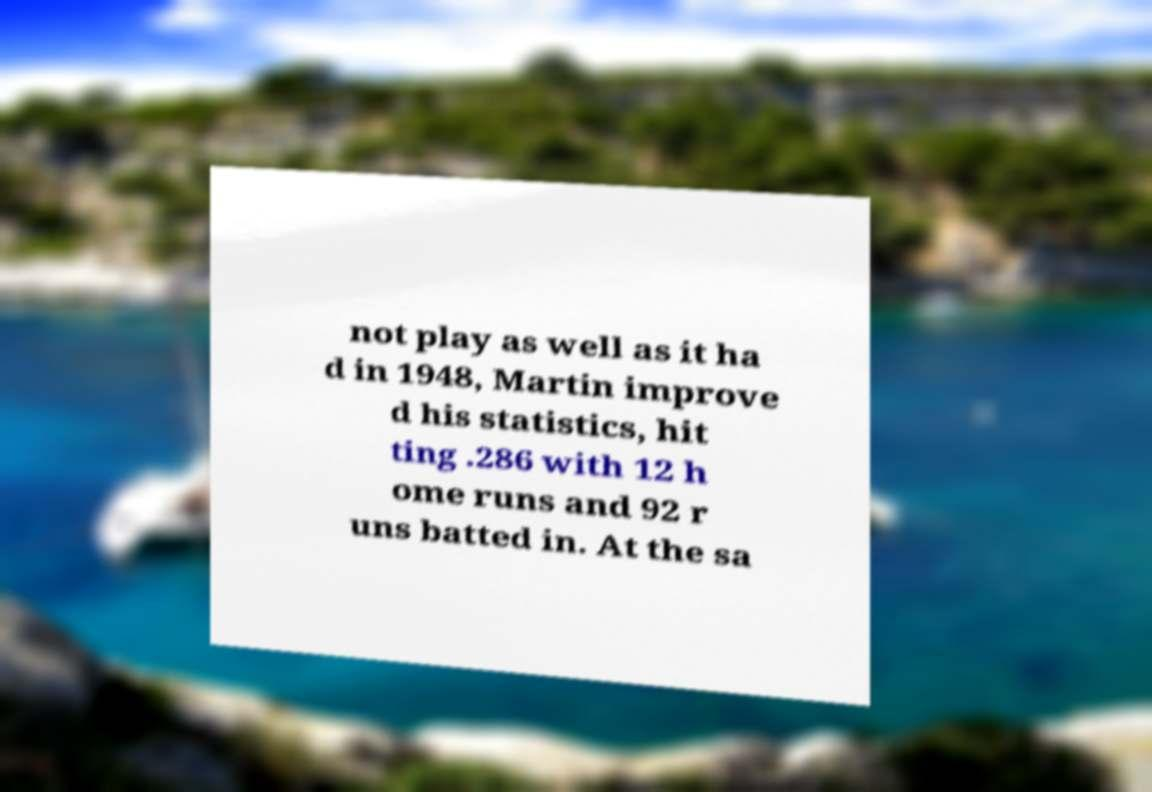For documentation purposes, I need the text within this image transcribed. Could you provide that? not play as well as it ha d in 1948, Martin improve d his statistics, hit ting .286 with 12 h ome runs and 92 r uns batted in. At the sa 